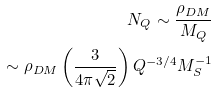<formula> <loc_0><loc_0><loc_500><loc_500>N _ { Q } \sim \frac { \rho _ { D M } } { M _ { Q } } \\ \sim \rho _ { D M } \left ( \frac { 3 } { 4 \pi \sqrt { 2 } } \right ) Q ^ { - 3 / 4 } M _ { S } ^ { - 1 }</formula> 